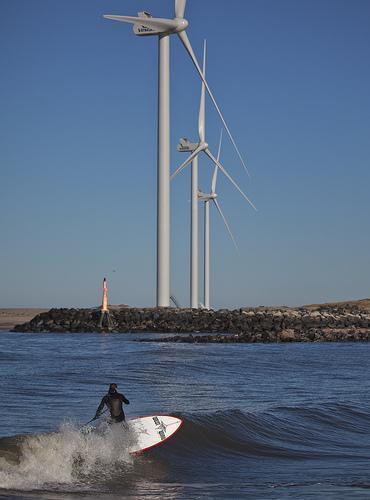How many windmills?
Give a very brief answer. 3. How many windmills are there?
Give a very brief answer. 3. How many people are pictured?
Give a very brief answer. 1. 